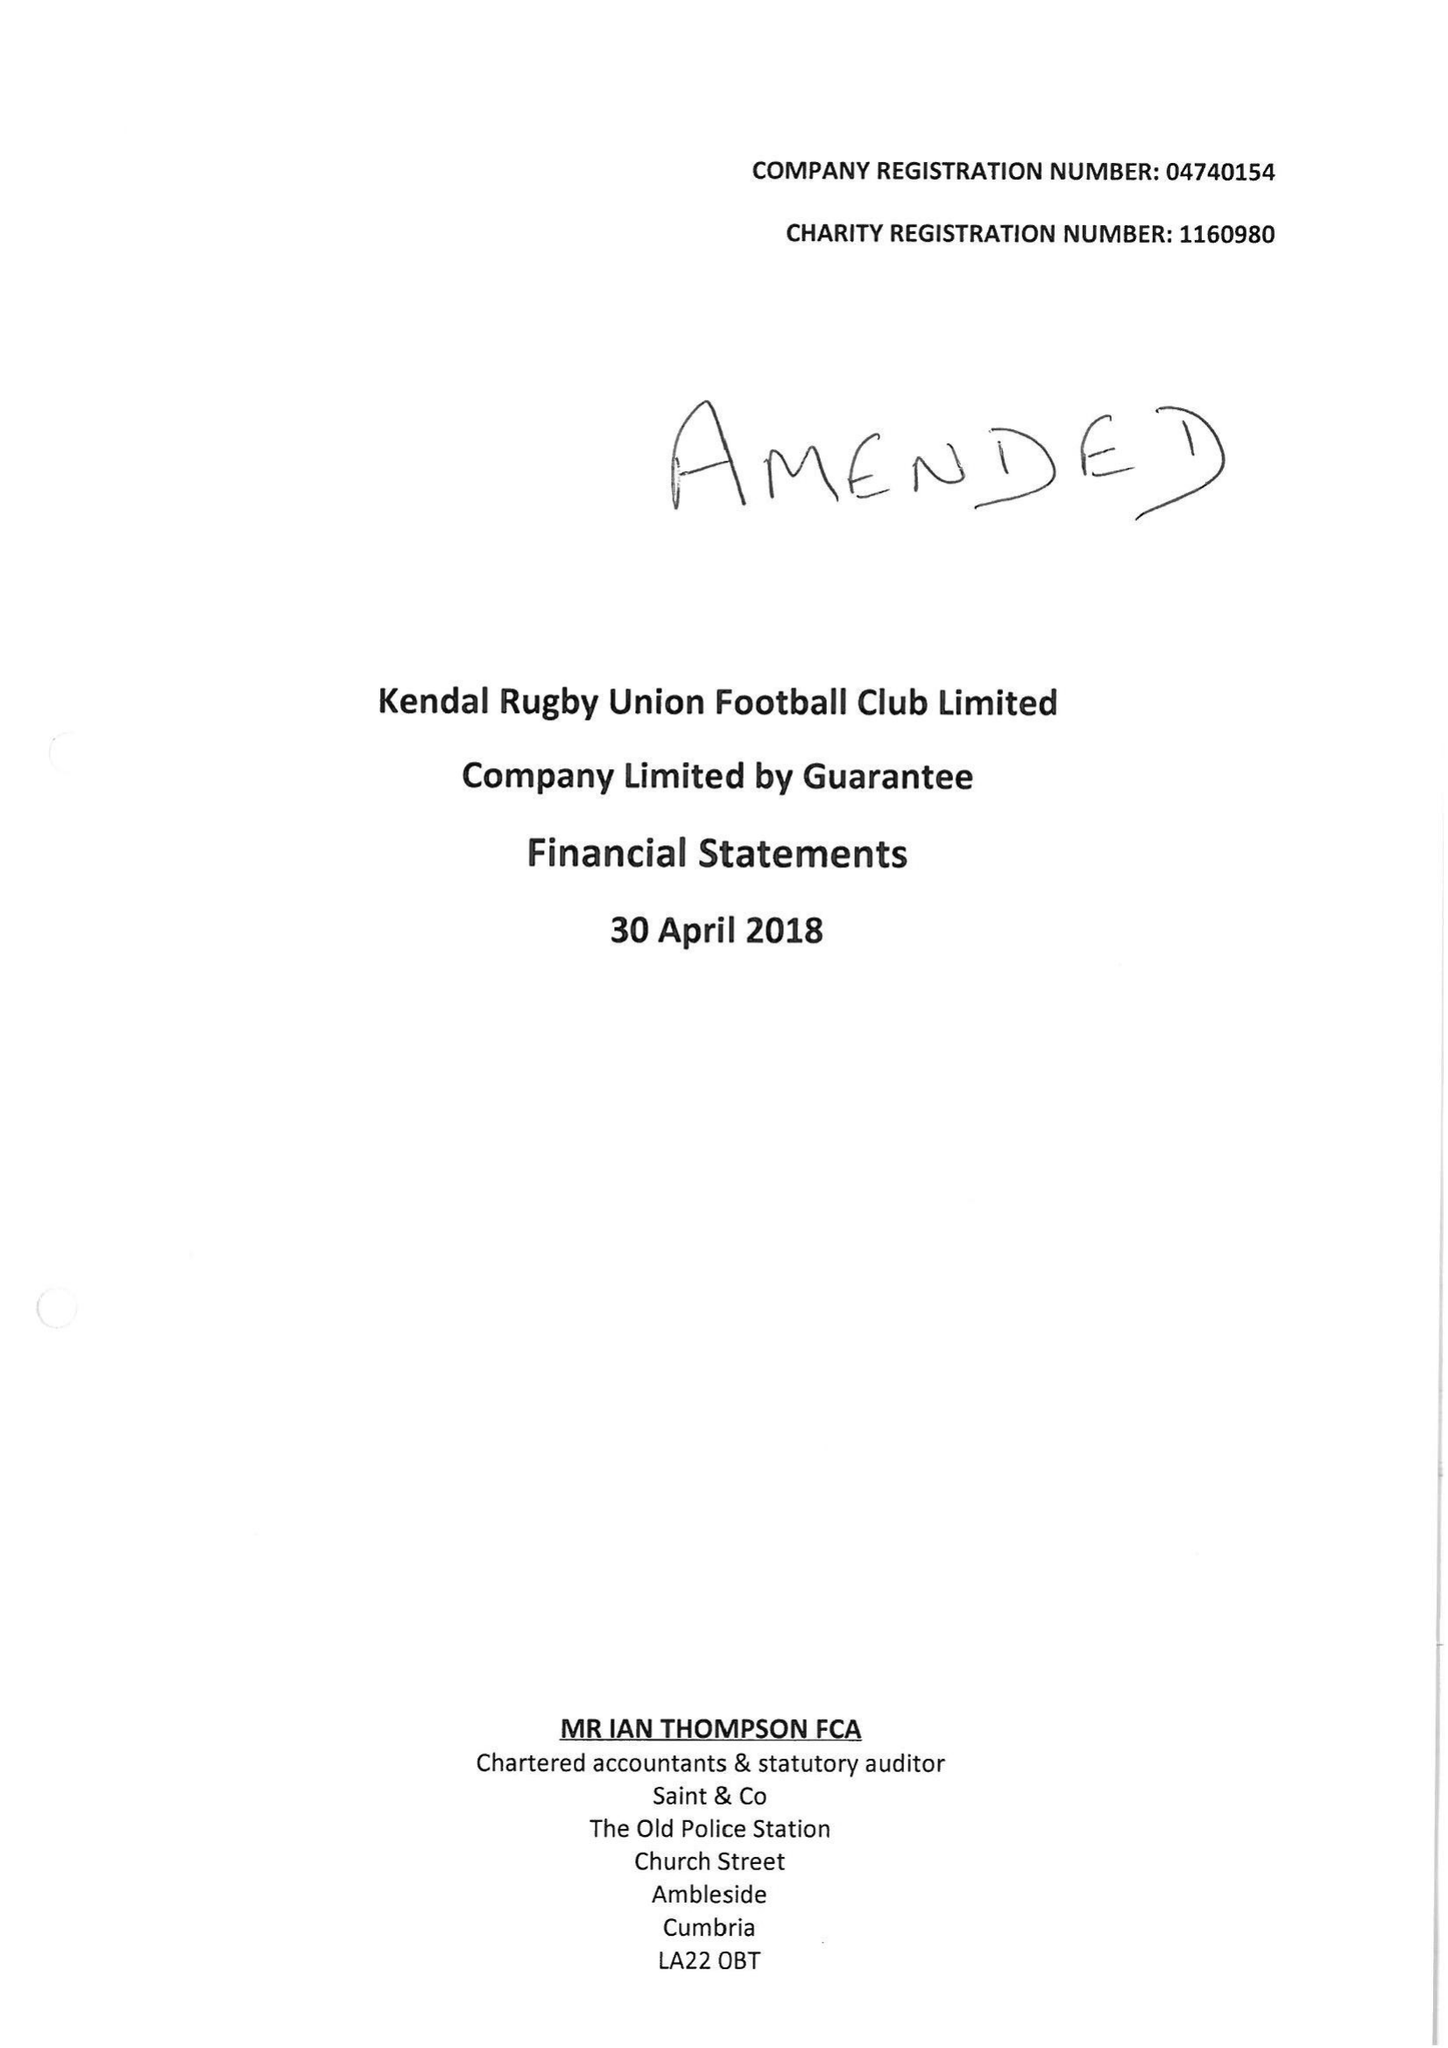What is the value for the spending_annually_in_british_pounds?
Answer the question using a single word or phrase. 356564.00 